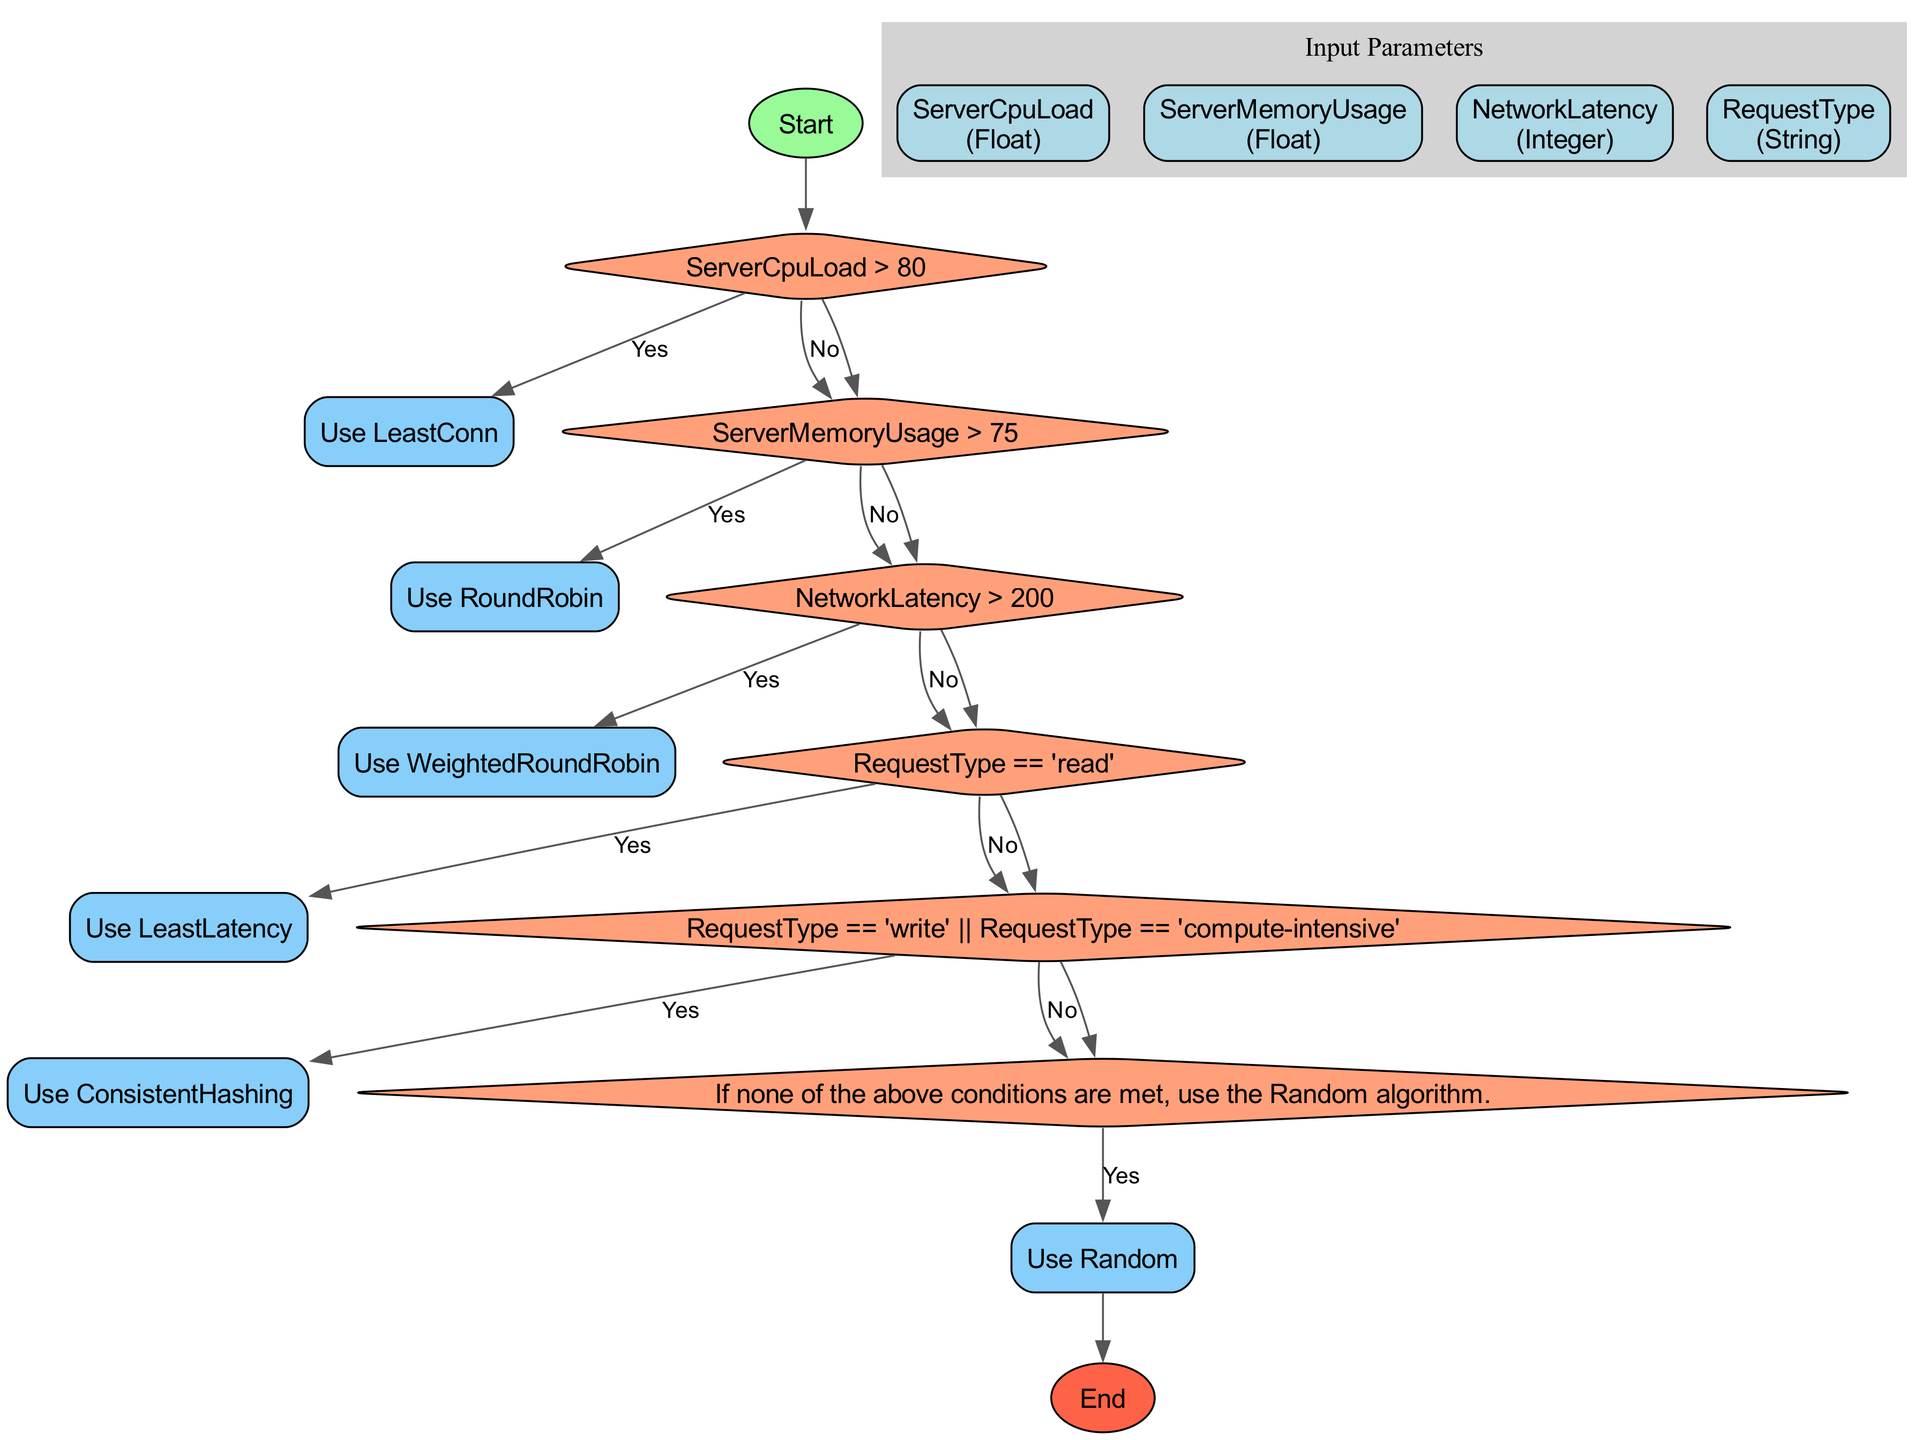What is the first action taken in the flowchart? The flowchart begins with the "Start" node which leads to the input parameters. There is no specified action taken at the start, as it primarily initiates the decision process.
Answer: Start How many input parameters are present in the diagram? The diagram contains four distinct input parameters as defined in the input section, each representing different metrics relevant for the load balancing decision.
Answer: 4 What algorithm is selected if the server CPU load exceeds 80? According to the decision nodes, if the CPU load is greater than 80%, the flowchart directs to using the Least Connections algorithm as the selected action.
Answer: Least Connections If the request type is "read", which algorithm will be used? The condition checks if the request type is specifically "read". If this condition is met, the algorithm chosen is Least Latency, indicating a focused approach based on the request type.
Answer: Least Latency What happens if network latency is greater than 200 milliseconds? In this case, the decision path indicates that the Weighted Round Robin algorithm should be utilized, switching based on the specified network condition to achieve more effective load management.
Answer: Weighted Round Robin What is the output if none of the conditions are satisfied? Under default conditions set within the flowchart, if none of the prior conditions are met, the algorithm selected will be Random, indicating a fallback strategy to handle unspecified conditions.
Answer: Random How do "write" and "compute-intensive" requests influence algorithm choice? Both request types funnel into the same decision branch leading to the use of the Consistent Hashing algorithm, highlighting a shared response strategy for these specific request classifications.
Answer: Consistent Hashing What visual shape represents the decision-making nodes in the diagram? The decision-making nodes are represented as diamonds within the flowchart, which is a typical representation indicating conditional logic and pathways based on different states or evaluations.
Answer: Diamond What types of algorithms are depicted in the algorithm use nodes? The algorithms chosen at various points include Least Connections, Round Robin, Weighted Round Robin, Least Latency, Consistent Hashing, and Random, demonstrating a range of load balancing strategies tailored to different conditions.
Answer: Least Connections, Round Robin, Weighted Round Robin, Least Latency, Consistent Hashing, Random 